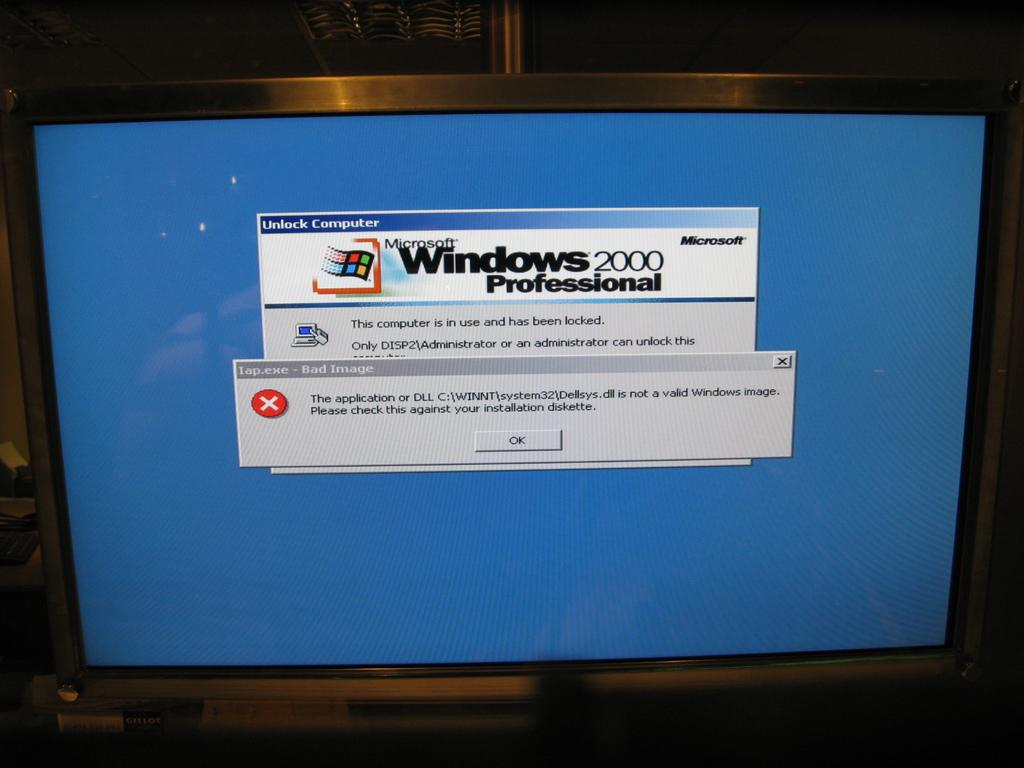<image>
Summarize the visual content of the image. A computer monitor running Windows 2000 with an error shown. 